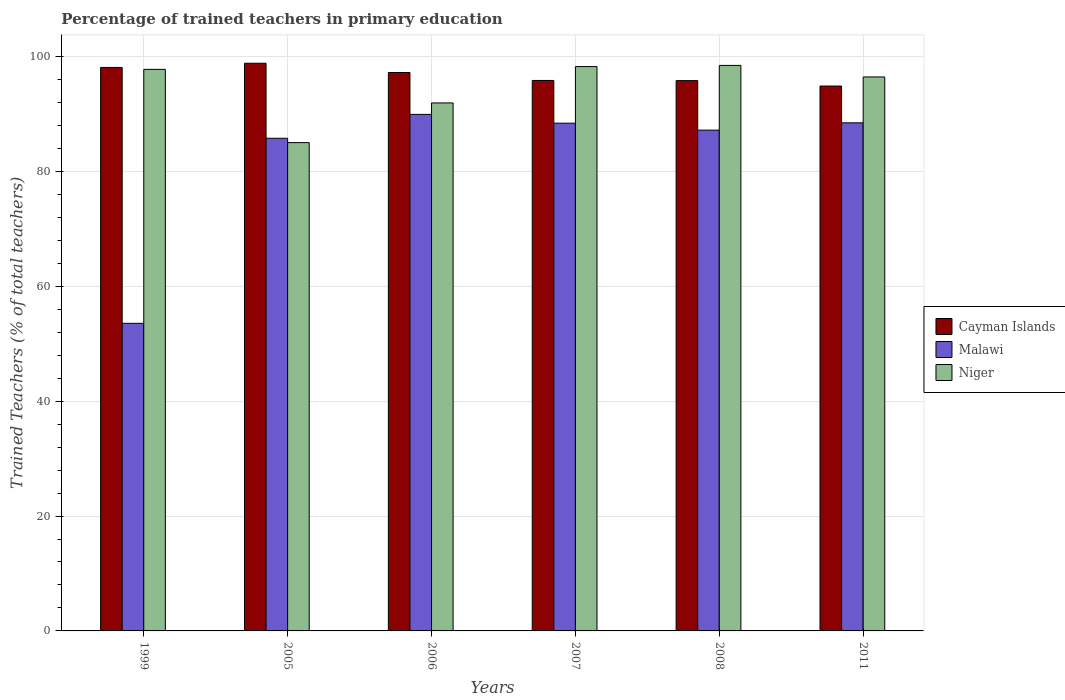Are the number of bars per tick equal to the number of legend labels?
Offer a very short reply. Yes. Are the number of bars on each tick of the X-axis equal?
Make the answer very short. Yes. How many bars are there on the 5th tick from the left?
Provide a short and direct response. 3. How many bars are there on the 2nd tick from the right?
Offer a terse response. 3. What is the label of the 2nd group of bars from the left?
Your response must be concise. 2005. What is the percentage of trained teachers in Cayman Islands in 1999?
Offer a terse response. 98.09. Across all years, what is the maximum percentage of trained teachers in Malawi?
Provide a succinct answer. 89.92. Across all years, what is the minimum percentage of trained teachers in Cayman Islands?
Give a very brief answer. 94.85. In which year was the percentage of trained teachers in Niger minimum?
Keep it short and to the point. 2005. What is the total percentage of trained teachers in Malawi in the graph?
Ensure brevity in your answer.  493.22. What is the difference between the percentage of trained teachers in Malawi in 1999 and that in 2005?
Offer a very short reply. -32.22. What is the difference between the percentage of trained teachers in Cayman Islands in 2005 and the percentage of trained teachers in Niger in 2006?
Provide a short and direct response. 6.91. What is the average percentage of trained teachers in Cayman Islands per year?
Provide a succinct answer. 96.76. In the year 2006, what is the difference between the percentage of trained teachers in Niger and percentage of trained teachers in Malawi?
Give a very brief answer. 1.99. In how many years, is the percentage of trained teachers in Niger greater than 16 %?
Provide a short and direct response. 6. What is the ratio of the percentage of trained teachers in Cayman Islands in 1999 to that in 2005?
Keep it short and to the point. 0.99. Is the percentage of trained teachers in Cayman Islands in 2006 less than that in 2011?
Offer a very short reply. No. What is the difference between the highest and the second highest percentage of trained teachers in Niger?
Keep it short and to the point. 0.2. What is the difference between the highest and the lowest percentage of trained teachers in Niger?
Ensure brevity in your answer.  13.44. In how many years, is the percentage of trained teachers in Cayman Islands greater than the average percentage of trained teachers in Cayman Islands taken over all years?
Provide a succinct answer. 3. What does the 2nd bar from the left in 2006 represents?
Your response must be concise. Malawi. What does the 2nd bar from the right in 2005 represents?
Provide a short and direct response. Malawi. How many bars are there?
Offer a terse response. 18. Are all the bars in the graph horizontal?
Your response must be concise. No. How many years are there in the graph?
Provide a short and direct response. 6. Are the values on the major ticks of Y-axis written in scientific E-notation?
Your answer should be compact. No. Does the graph contain any zero values?
Your response must be concise. No. Does the graph contain grids?
Provide a succinct answer. Yes. Where does the legend appear in the graph?
Your answer should be very brief. Center right. What is the title of the graph?
Ensure brevity in your answer.  Percentage of trained teachers in primary education. What is the label or title of the X-axis?
Offer a terse response. Years. What is the label or title of the Y-axis?
Keep it short and to the point. Trained Teachers (% of total teachers). What is the Trained Teachers (% of total teachers) of Cayman Islands in 1999?
Give a very brief answer. 98.09. What is the Trained Teachers (% of total teachers) in Malawi in 1999?
Keep it short and to the point. 53.54. What is the Trained Teachers (% of total teachers) in Niger in 1999?
Your answer should be very brief. 97.75. What is the Trained Teachers (% of total teachers) of Cayman Islands in 2005?
Provide a succinct answer. 98.81. What is the Trained Teachers (% of total teachers) in Malawi in 2005?
Make the answer very short. 85.76. What is the Trained Teachers (% of total teachers) in Niger in 2005?
Your answer should be compact. 85. What is the Trained Teachers (% of total teachers) of Cayman Islands in 2006?
Provide a succinct answer. 97.2. What is the Trained Teachers (% of total teachers) of Malawi in 2006?
Offer a terse response. 89.92. What is the Trained Teachers (% of total teachers) of Niger in 2006?
Your answer should be compact. 91.91. What is the Trained Teachers (% of total teachers) of Cayman Islands in 2007?
Your response must be concise. 95.82. What is the Trained Teachers (% of total teachers) in Malawi in 2007?
Offer a terse response. 88.38. What is the Trained Teachers (% of total teachers) in Niger in 2007?
Offer a terse response. 98.24. What is the Trained Teachers (% of total teachers) of Cayman Islands in 2008?
Make the answer very short. 95.79. What is the Trained Teachers (% of total teachers) of Malawi in 2008?
Provide a short and direct response. 87.17. What is the Trained Teachers (% of total teachers) of Niger in 2008?
Provide a short and direct response. 98.44. What is the Trained Teachers (% of total teachers) of Cayman Islands in 2011?
Provide a short and direct response. 94.85. What is the Trained Teachers (% of total teachers) in Malawi in 2011?
Provide a succinct answer. 88.45. What is the Trained Teachers (% of total teachers) of Niger in 2011?
Your answer should be compact. 96.43. Across all years, what is the maximum Trained Teachers (% of total teachers) of Cayman Islands?
Your response must be concise. 98.81. Across all years, what is the maximum Trained Teachers (% of total teachers) in Malawi?
Provide a short and direct response. 89.92. Across all years, what is the maximum Trained Teachers (% of total teachers) in Niger?
Give a very brief answer. 98.44. Across all years, what is the minimum Trained Teachers (% of total teachers) of Cayman Islands?
Provide a short and direct response. 94.85. Across all years, what is the minimum Trained Teachers (% of total teachers) in Malawi?
Offer a very short reply. 53.54. Across all years, what is the minimum Trained Teachers (% of total teachers) of Niger?
Your response must be concise. 85. What is the total Trained Teachers (% of total teachers) of Cayman Islands in the graph?
Your response must be concise. 580.57. What is the total Trained Teachers (% of total teachers) of Malawi in the graph?
Keep it short and to the point. 493.22. What is the total Trained Teachers (% of total teachers) of Niger in the graph?
Your answer should be compact. 567.77. What is the difference between the Trained Teachers (% of total teachers) in Cayman Islands in 1999 and that in 2005?
Offer a very short reply. -0.73. What is the difference between the Trained Teachers (% of total teachers) of Malawi in 1999 and that in 2005?
Make the answer very short. -32.22. What is the difference between the Trained Teachers (% of total teachers) of Niger in 1999 and that in 2005?
Ensure brevity in your answer.  12.75. What is the difference between the Trained Teachers (% of total teachers) of Cayman Islands in 1999 and that in 2006?
Give a very brief answer. 0.88. What is the difference between the Trained Teachers (% of total teachers) of Malawi in 1999 and that in 2006?
Give a very brief answer. -36.37. What is the difference between the Trained Teachers (% of total teachers) in Niger in 1999 and that in 2006?
Your answer should be very brief. 5.84. What is the difference between the Trained Teachers (% of total teachers) of Cayman Islands in 1999 and that in 2007?
Offer a terse response. 2.27. What is the difference between the Trained Teachers (% of total teachers) in Malawi in 1999 and that in 2007?
Provide a short and direct response. -34.84. What is the difference between the Trained Teachers (% of total teachers) of Niger in 1999 and that in 2007?
Your answer should be very brief. -0.48. What is the difference between the Trained Teachers (% of total teachers) in Cayman Islands in 1999 and that in 2008?
Keep it short and to the point. 2.29. What is the difference between the Trained Teachers (% of total teachers) of Malawi in 1999 and that in 2008?
Give a very brief answer. -33.63. What is the difference between the Trained Teachers (% of total teachers) of Niger in 1999 and that in 2008?
Your answer should be very brief. -0.69. What is the difference between the Trained Teachers (% of total teachers) in Cayman Islands in 1999 and that in 2011?
Your response must be concise. 3.24. What is the difference between the Trained Teachers (% of total teachers) of Malawi in 1999 and that in 2011?
Make the answer very short. -34.9. What is the difference between the Trained Teachers (% of total teachers) in Niger in 1999 and that in 2011?
Your answer should be very brief. 1.32. What is the difference between the Trained Teachers (% of total teachers) of Cayman Islands in 2005 and that in 2006?
Your response must be concise. 1.61. What is the difference between the Trained Teachers (% of total teachers) in Malawi in 2005 and that in 2006?
Your answer should be compact. -4.16. What is the difference between the Trained Teachers (% of total teachers) of Niger in 2005 and that in 2006?
Ensure brevity in your answer.  -6.91. What is the difference between the Trained Teachers (% of total teachers) in Cayman Islands in 2005 and that in 2007?
Provide a succinct answer. 2.99. What is the difference between the Trained Teachers (% of total teachers) in Malawi in 2005 and that in 2007?
Provide a short and direct response. -2.62. What is the difference between the Trained Teachers (% of total teachers) in Niger in 2005 and that in 2007?
Provide a short and direct response. -13.24. What is the difference between the Trained Teachers (% of total teachers) in Cayman Islands in 2005 and that in 2008?
Ensure brevity in your answer.  3.02. What is the difference between the Trained Teachers (% of total teachers) in Malawi in 2005 and that in 2008?
Make the answer very short. -1.41. What is the difference between the Trained Teachers (% of total teachers) of Niger in 2005 and that in 2008?
Your response must be concise. -13.44. What is the difference between the Trained Teachers (% of total teachers) of Cayman Islands in 2005 and that in 2011?
Your answer should be very brief. 3.97. What is the difference between the Trained Teachers (% of total teachers) in Malawi in 2005 and that in 2011?
Your answer should be very brief. -2.69. What is the difference between the Trained Teachers (% of total teachers) of Niger in 2005 and that in 2011?
Provide a succinct answer. -11.43. What is the difference between the Trained Teachers (% of total teachers) of Cayman Islands in 2006 and that in 2007?
Your response must be concise. 1.38. What is the difference between the Trained Teachers (% of total teachers) of Malawi in 2006 and that in 2007?
Your response must be concise. 1.53. What is the difference between the Trained Teachers (% of total teachers) in Niger in 2006 and that in 2007?
Provide a short and direct response. -6.33. What is the difference between the Trained Teachers (% of total teachers) of Cayman Islands in 2006 and that in 2008?
Your response must be concise. 1.41. What is the difference between the Trained Teachers (% of total teachers) in Malawi in 2006 and that in 2008?
Keep it short and to the point. 2.74. What is the difference between the Trained Teachers (% of total teachers) of Niger in 2006 and that in 2008?
Provide a succinct answer. -6.53. What is the difference between the Trained Teachers (% of total teachers) in Cayman Islands in 2006 and that in 2011?
Your answer should be very brief. 2.35. What is the difference between the Trained Teachers (% of total teachers) of Malawi in 2006 and that in 2011?
Provide a succinct answer. 1.47. What is the difference between the Trained Teachers (% of total teachers) in Niger in 2006 and that in 2011?
Keep it short and to the point. -4.52. What is the difference between the Trained Teachers (% of total teachers) of Cayman Islands in 2007 and that in 2008?
Your answer should be very brief. 0.03. What is the difference between the Trained Teachers (% of total teachers) of Malawi in 2007 and that in 2008?
Your answer should be compact. 1.21. What is the difference between the Trained Teachers (% of total teachers) in Niger in 2007 and that in 2008?
Ensure brevity in your answer.  -0.2. What is the difference between the Trained Teachers (% of total teachers) in Cayman Islands in 2007 and that in 2011?
Provide a short and direct response. 0.97. What is the difference between the Trained Teachers (% of total teachers) of Malawi in 2007 and that in 2011?
Offer a terse response. -0.06. What is the difference between the Trained Teachers (% of total teachers) of Niger in 2007 and that in 2011?
Your answer should be very brief. 1.81. What is the difference between the Trained Teachers (% of total teachers) of Cayman Islands in 2008 and that in 2011?
Offer a very short reply. 0.94. What is the difference between the Trained Teachers (% of total teachers) of Malawi in 2008 and that in 2011?
Your response must be concise. -1.27. What is the difference between the Trained Teachers (% of total teachers) in Niger in 2008 and that in 2011?
Offer a terse response. 2.01. What is the difference between the Trained Teachers (% of total teachers) in Cayman Islands in 1999 and the Trained Teachers (% of total teachers) in Malawi in 2005?
Offer a terse response. 12.33. What is the difference between the Trained Teachers (% of total teachers) in Cayman Islands in 1999 and the Trained Teachers (% of total teachers) in Niger in 2005?
Your answer should be very brief. 13.08. What is the difference between the Trained Teachers (% of total teachers) in Malawi in 1999 and the Trained Teachers (% of total teachers) in Niger in 2005?
Offer a very short reply. -31.46. What is the difference between the Trained Teachers (% of total teachers) of Cayman Islands in 1999 and the Trained Teachers (% of total teachers) of Malawi in 2006?
Offer a terse response. 8.17. What is the difference between the Trained Teachers (% of total teachers) in Cayman Islands in 1999 and the Trained Teachers (% of total teachers) in Niger in 2006?
Offer a very short reply. 6.18. What is the difference between the Trained Teachers (% of total teachers) of Malawi in 1999 and the Trained Teachers (% of total teachers) of Niger in 2006?
Provide a succinct answer. -38.36. What is the difference between the Trained Teachers (% of total teachers) in Cayman Islands in 1999 and the Trained Teachers (% of total teachers) in Malawi in 2007?
Your response must be concise. 9.7. What is the difference between the Trained Teachers (% of total teachers) of Cayman Islands in 1999 and the Trained Teachers (% of total teachers) of Niger in 2007?
Keep it short and to the point. -0.15. What is the difference between the Trained Teachers (% of total teachers) in Malawi in 1999 and the Trained Teachers (% of total teachers) in Niger in 2007?
Keep it short and to the point. -44.69. What is the difference between the Trained Teachers (% of total teachers) of Cayman Islands in 1999 and the Trained Teachers (% of total teachers) of Malawi in 2008?
Offer a very short reply. 10.91. What is the difference between the Trained Teachers (% of total teachers) in Cayman Islands in 1999 and the Trained Teachers (% of total teachers) in Niger in 2008?
Your answer should be compact. -0.35. What is the difference between the Trained Teachers (% of total teachers) of Malawi in 1999 and the Trained Teachers (% of total teachers) of Niger in 2008?
Ensure brevity in your answer.  -44.89. What is the difference between the Trained Teachers (% of total teachers) in Cayman Islands in 1999 and the Trained Teachers (% of total teachers) in Malawi in 2011?
Your answer should be compact. 9.64. What is the difference between the Trained Teachers (% of total teachers) in Cayman Islands in 1999 and the Trained Teachers (% of total teachers) in Niger in 2011?
Keep it short and to the point. 1.66. What is the difference between the Trained Teachers (% of total teachers) of Malawi in 1999 and the Trained Teachers (% of total teachers) of Niger in 2011?
Make the answer very short. -42.89. What is the difference between the Trained Teachers (% of total teachers) in Cayman Islands in 2005 and the Trained Teachers (% of total teachers) in Malawi in 2006?
Make the answer very short. 8.9. What is the difference between the Trained Teachers (% of total teachers) of Cayman Islands in 2005 and the Trained Teachers (% of total teachers) of Niger in 2006?
Your answer should be very brief. 6.91. What is the difference between the Trained Teachers (% of total teachers) of Malawi in 2005 and the Trained Teachers (% of total teachers) of Niger in 2006?
Keep it short and to the point. -6.15. What is the difference between the Trained Teachers (% of total teachers) of Cayman Islands in 2005 and the Trained Teachers (% of total teachers) of Malawi in 2007?
Your response must be concise. 10.43. What is the difference between the Trained Teachers (% of total teachers) of Cayman Islands in 2005 and the Trained Teachers (% of total teachers) of Niger in 2007?
Your answer should be compact. 0.58. What is the difference between the Trained Teachers (% of total teachers) in Malawi in 2005 and the Trained Teachers (% of total teachers) in Niger in 2007?
Give a very brief answer. -12.48. What is the difference between the Trained Teachers (% of total teachers) of Cayman Islands in 2005 and the Trained Teachers (% of total teachers) of Malawi in 2008?
Your answer should be very brief. 11.64. What is the difference between the Trained Teachers (% of total teachers) of Cayman Islands in 2005 and the Trained Teachers (% of total teachers) of Niger in 2008?
Keep it short and to the point. 0.38. What is the difference between the Trained Teachers (% of total teachers) of Malawi in 2005 and the Trained Teachers (% of total teachers) of Niger in 2008?
Your answer should be compact. -12.68. What is the difference between the Trained Teachers (% of total teachers) in Cayman Islands in 2005 and the Trained Teachers (% of total teachers) in Malawi in 2011?
Offer a terse response. 10.37. What is the difference between the Trained Teachers (% of total teachers) in Cayman Islands in 2005 and the Trained Teachers (% of total teachers) in Niger in 2011?
Provide a succinct answer. 2.38. What is the difference between the Trained Teachers (% of total teachers) of Malawi in 2005 and the Trained Teachers (% of total teachers) of Niger in 2011?
Your response must be concise. -10.67. What is the difference between the Trained Teachers (% of total teachers) in Cayman Islands in 2006 and the Trained Teachers (% of total teachers) in Malawi in 2007?
Your answer should be compact. 8.82. What is the difference between the Trained Teachers (% of total teachers) of Cayman Islands in 2006 and the Trained Teachers (% of total teachers) of Niger in 2007?
Make the answer very short. -1.03. What is the difference between the Trained Teachers (% of total teachers) in Malawi in 2006 and the Trained Teachers (% of total teachers) in Niger in 2007?
Offer a terse response. -8.32. What is the difference between the Trained Teachers (% of total teachers) of Cayman Islands in 2006 and the Trained Teachers (% of total teachers) of Malawi in 2008?
Give a very brief answer. 10.03. What is the difference between the Trained Teachers (% of total teachers) of Cayman Islands in 2006 and the Trained Teachers (% of total teachers) of Niger in 2008?
Offer a very short reply. -1.23. What is the difference between the Trained Teachers (% of total teachers) of Malawi in 2006 and the Trained Teachers (% of total teachers) of Niger in 2008?
Make the answer very short. -8.52. What is the difference between the Trained Teachers (% of total teachers) of Cayman Islands in 2006 and the Trained Teachers (% of total teachers) of Malawi in 2011?
Provide a succinct answer. 8.76. What is the difference between the Trained Teachers (% of total teachers) in Cayman Islands in 2006 and the Trained Teachers (% of total teachers) in Niger in 2011?
Give a very brief answer. 0.77. What is the difference between the Trained Teachers (% of total teachers) of Malawi in 2006 and the Trained Teachers (% of total teachers) of Niger in 2011?
Your response must be concise. -6.51. What is the difference between the Trained Teachers (% of total teachers) in Cayman Islands in 2007 and the Trained Teachers (% of total teachers) in Malawi in 2008?
Keep it short and to the point. 8.65. What is the difference between the Trained Teachers (% of total teachers) of Cayman Islands in 2007 and the Trained Teachers (% of total teachers) of Niger in 2008?
Make the answer very short. -2.62. What is the difference between the Trained Teachers (% of total teachers) of Malawi in 2007 and the Trained Teachers (% of total teachers) of Niger in 2008?
Give a very brief answer. -10.06. What is the difference between the Trained Teachers (% of total teachers) in Cayman Islands in 2007 and the Trained Teachers (% of total teachers) in Malawi in 2011?
Keep it short and to the point. 7.37. What is the difference between the Trained Teachers (% of total teachers) in Cayman Islands in 2007 and the Trained Teachers (% of total teachers) in Niger in 2011?
Ensure brevity in your answer.  -0.61. What is the difference between the Trained Teachers (% of total teachers) in Malawi in 2007 and the Trained Teachers (% of total teachers) in Niger in 2011?
Ensure brevity in your answer.  -8.05. What is the difference between the Trained Teachers (% of total teachers) in Cayman Islands in 2008 and the Trained Teachers (% of total teachers) in Malawi in 2011?
Make the answer very short. 7.35. What is the difference between the Trained Teachers (% of total teachers) of Cayman Islands in 2008 and the Trained Teachers (% of total teachers) of Niger in 2011?
Offer a terse response. -0.64. What is the difference between the Trained Teachers (% of total teachers) in Malawi in 2008 and the Trained Teachers (% of total teachers) in Niger in 2011?
Your answer should be very brief. -9.26. What is the average Trained Teachers (% of total teachers) in Cayman Islands per year?
Give a very brief answer. 96.76. What is the average Trained Teachers (% of total teachers) in Malawi per year?
Keep it short and to the point. 82.2. What is the average Trained Teachers (% of total teachers) in Niger per year?
Your response must be concise. 94.63. In the year 1999, what is the difference between the Trained Teachers (% of total teachers) of Cayman Islands and Trained Teachers (% of total teachers) of Malawi?
Offer a terse response. 44.54. In the year 1999, what is the difference between the Trained Teachers (% of total teachers) in Cayman Islands and Trained Teachers (% of total teachers) in Niger?
Offer a terse response. 0.33. In the year 1999, what is the difference between the Trained Teachers (% of total teachers) of Malawi and Trained Teachers (% of total teachers) of Niger?
Provide a succinct answer. -44.21. In the year 2005, what is the difference between the Trained Teachers (% of total teachers) of Cayman Islands and Trained Teachers (% of total teachers) of Malawi?
Give a very brief answer. 13.05. In the year 2005, what is the difference between the Trained Teachers (% of total teachers) of Cayman Islands and Trained Teachers (% of total teachers) of Niger?
Make the answer very short. 13.81. In the year 2005, what is the difference between the Trained Teachers (% of total teachers) in Malawi and Trained Teachers (% of total teachers) in Niger?
Your answer should be compact. 0.76. In the year 2006, what is the difference between the Trained Teachers (% of total teachers) in Cayman Islands and Trained Teachers (% of total teachers) in Malawi?
Provide a succinct answer. 7.29. In the year 2006, what is the difference between the Trained Teachers (% of total teachers) in Cayman Islands and Trained Teachers (% of total teachers) in Niger?
Offer a very short reply. 5.29. In the year 2006, what is the difference between the Trained Teachers (% of total teachers) of Malawi and Trained Teachers (% of total teachers) of Niger?
Your answer should be very brief. -1.99. In the year 2007, what is the difference between the Trained Teachers (% of total teachers) of Cayman Islands and Trained Teachers (% of total teachers) of Malawi?
Offer a terse response. 7.44. In the year 2007, what is the difference between the Trained Teachers (% of total teachers) of Cayman Islands and Trained Teachers (% of total teachers) of Niger?
Your answer should be very brief. -2.42. In the year 2007, what is the difference between the Trained Teachers (% of total teachers) in Malawi and Trained Teachers (% of total teachers) in Niger?
Your response must be concise. -9.85. In the year 2008, what is the difference between the Trained Teachers (% of total teachers) of Cayman Islands and Trained Teachers (% of total teachers) of Malawi?
Your answer should be very brief. 8.62. In the year 2008, what is the difference between the Trained Teachers (% of total teachers) of Cayman Islands and Trained Teachers (% of total teachers) of Niger?
Your response must be concise. -2.64. In the year 2008, what is the difference between the Trained Teachers (% of total teachers) of Malawi and Trained Teachers (% of total teachers) of Niger?
Provide a short and direct response. -11.27. In the year 2011, what is the difference between the Trained Teachers (% of total teachers) in Cayman Islands and Trained Teachers (% of total teachers) in Malawi?
Ensure brevity in your answer.  6.4. In the year 2011, what is the difference between the Trained Teachers (% of total teachers) of Cayman Islands and Trained Teachers (% of total teachers) of Niger?
Offer a very short reply. -1.58. In the year 2011, what is the difference between the Trained Teachers (% of total teachers) in Malawi and Trained Teachers (% of total teachers) in Niger?
Provide a succinct answer. -7.98. What is the ratio of the Trained Teachers (% of total teachers) of Cayman Islands in 1999 to that in 2005?
Provide a short and direct response. 0.99. What is the ratio of the Trained Teachers (% of total teachers) in Malawi in 1999 to that in 2005?
Your answer should be compact. 0.62. What is the ratio of the Trained Teachers (% of total teachers) of Niger in 1999 to that in 2005?
Offer a terse response. 1.15. What is the ratio of the Trained Teachers (% of total teachers) of Cayman Islands in 1999 to that in 2006?
Keep it short and to the point. 1.01. What is the ratio of the Trained Teachers (% of total teachers) of Malawi in 1999 to that in 2006?
Offer a very short reply. 0.6. What is the ratio of the Trained Teachers (% of total teachers) of Niger in 1999 to that in 2006?
Provide a short and direct response. 1.06. What is the ratio of the Trained Teachers (% of total teachers) of Cayman Islands in 1999 to that in 2007?
Make the answer very short. 1.02. What is the ratio of the Trained Teachers (% of total teachers) in Malawi in 1999 to that in 2007?
Your response must be concise. 0.61. What is the ratio of the Trained Teachers (% of total teachers) in Niger in 1999 to that in 2007?
Offer a very short reply. 1. What is the ratio of the Trained Teachers (% of total teachers) in Cayman Islands in 1999 to that in 2008?
Make the answer very short. 1.02. What is the ratio of the Trained Teachers (% of total teachers) of Malawi in 1999 to that in 2008?
Offer a terse response. 0.61. What is the ratio of the Trained Teachers (% of total teachers) in Cayman Islands in 1999 to that in 2011?
Provide a short and direct response. 1.03. What is the ratio of the Trained Teachers (% of total teachers) of Malawi in 1999 to that in 2011?
Offer a terse response. 0.61. What is the ratio of the Trained Teachers (% of total teachers) of Niger in 1999 to that in 2011?
Your answer should be compact. 1.01. What is the ratio of the Trained Teachers (% of total teachers) in Cayman Islands in 2005 to that in 2006?
Offer a terse response. 1.02. What is the ratio of the Trained Teachers (% of total teachers) of Malawi in 2005 to that in 2006?
Offer a terse response. 0.95. What is the ratio of the Trained Teachers (% of total teachers) in Niger in 2005 to that in 2006?
Keep it short and to the point. 0.92. What is the ratio of the Trained Teachers (% of total teachers) of Cayman Islands in 2005 to that in 2007?
Offer a very short reply. 1.03. What is the ratio of the Trained Teachers (% of total teachers) in Malawi in 2005 to that in 2007?
Make the answer very short. 0.97. What is the ratio of the Trained Teachers (% of total teachers) of Niger in 2005 to that in 2007?
Your answer should be compact. 0.87. What is the ratio of the Trained Teachers (% of total teachers) in Cayman Islands in 2005 to that in 2008?
Offer a terse response. 1.03. What is the ratio of the Trained Teachers (% of total teachers) of Malawi in 2005 to that in 2008?
Your answer should be very brief. 0.98. What is the ratio of the Trained Teachers (% of total teachers) in Niger in 2005 to that in 2008?
Your answer should be compact. 0.86. What is the ratio of the Trained Teachers (% of total teachers) of Cayman Islands in 2005 to that in 2011?
Your answer should be compact. 1.04. What is the ratio of the Trained Teachers (% of total teachers) of Malawi in 2005 to that in 2011?
Your response must be concise. 0.97. What is the ratio of the Trained Teachers (% of total teachers) in Niger in 2005 to that in 2011?
Your response must be concise. 0.88. What is the ratio of the Trained Teachers (% of total teachers) of Cayman Islands in 2006 to that in 2007?
Give a very brief answer. 1.01. What is the ratio of the Trained Teachers (% of total teachers) in Malawi in 2006 to that in 2007?
Ensure brevity in your answer.  1.02. What is the ratio of the Trained Teachers (% of total teachers) of Niger in 2006 to that in 2007?
Provide a short and direct response. 0.94. What is the ratio of the Trained Teachers (% of total teachers) of Cayman Islands in 2006 to that in 2008?
Provide a succinct answer. 1.01. What is the ratio of the Trained Teachers (% of total teachers) of Malawi in 2006 to that in 2008?
Give a very brief answer. 1.03. What is the ratio of the Trained Teachers (% of total teachers) of Niger in 2006 to that in 2008?
Your answer should be very brief. 0.93. What is the ratio of the Trained Teachers (% of total teachers) of Cayman Islands in 2006 to that in 2011?
Offer a terse response. 1.02. What is the ratio of the Trained Teachers (% of total teachers) of Malawi in 2006 to that in 2011?
Offer a very short reply. 1.02. What is the ratio of the Trained Teachers (% of total teachers) in Niger in 2006 to that in 2011?
Provide a succinct answer. 0.95. What is the ratio of the Trained Teachers (% of total teachers) in Cayman Islands in 2007 to that in 2008?
Offer a very short reply. 1. What is the ratio of the Trained Teachers (% of total teachers) of Malawi in 2007 to that in 2008?
Your answer should be very brief. 1.01. What is the ratio of the Trained Teachers (% of total teachers) in Niger in 2007 to that in 2008?
Offer a terse response. 1. What is the ratio of the Trained Teachers (% of total teachers) in Cayman Islands in 2007 to that in 2011?
Give a very brief answer. 1.01. What is the ratio of the Trained Teachers (% of total teachers) of Malawi in 2007 to that in 2011?
Provide a short and direct response. 1. What is the ratio of the Trained Teachers (% of total teachers) in Niger in 2007 to that in 2011?
Ensure brevity in your answer.  1.02. What is the ratio of the Trained Teachers (% of total teachers) in Cayman Islands in 2008 to that in 2011?
Offer a very short reply. 1.01. What is the ratio of the Trained Teachers (% of total teachers) of Malawi in 2008 to that in 2011?
Ensure brevity in your answer.  0.99. What is the ratio of the Trained Teachers (% of total teachers) in Niger in 2008 to that in 2011?
Your answer should be compact. 1.02. What is the difference between the highest and the second highest Trained Teachers (% of total teachers) in Cayman Islands?
Offer a very short reply. 0.73. What is the difference between the highest and the second highest Trained Teachers (% of total teachers) of Malawi?
Offer a very short reply. 1.47. What is the difference between the highest and the second highest Trained Teachers (% of total teachers) of Niger?
Provide a succinct answer. 0.2. What is the difference between the highest and the lowest Trained Teachers (% of total teachers) of Cayman Islands?
Your response must be concise. 3.97. What is the difference between the highest and the lowest Trained Teachers (% of total teachers) of Malawi?
Offer a very short reply. 36.37. What is the difference between the highest and the lowest Trained Teachers (% of total teachers) in Niger?
Your answer should be very brief. 13.44. 